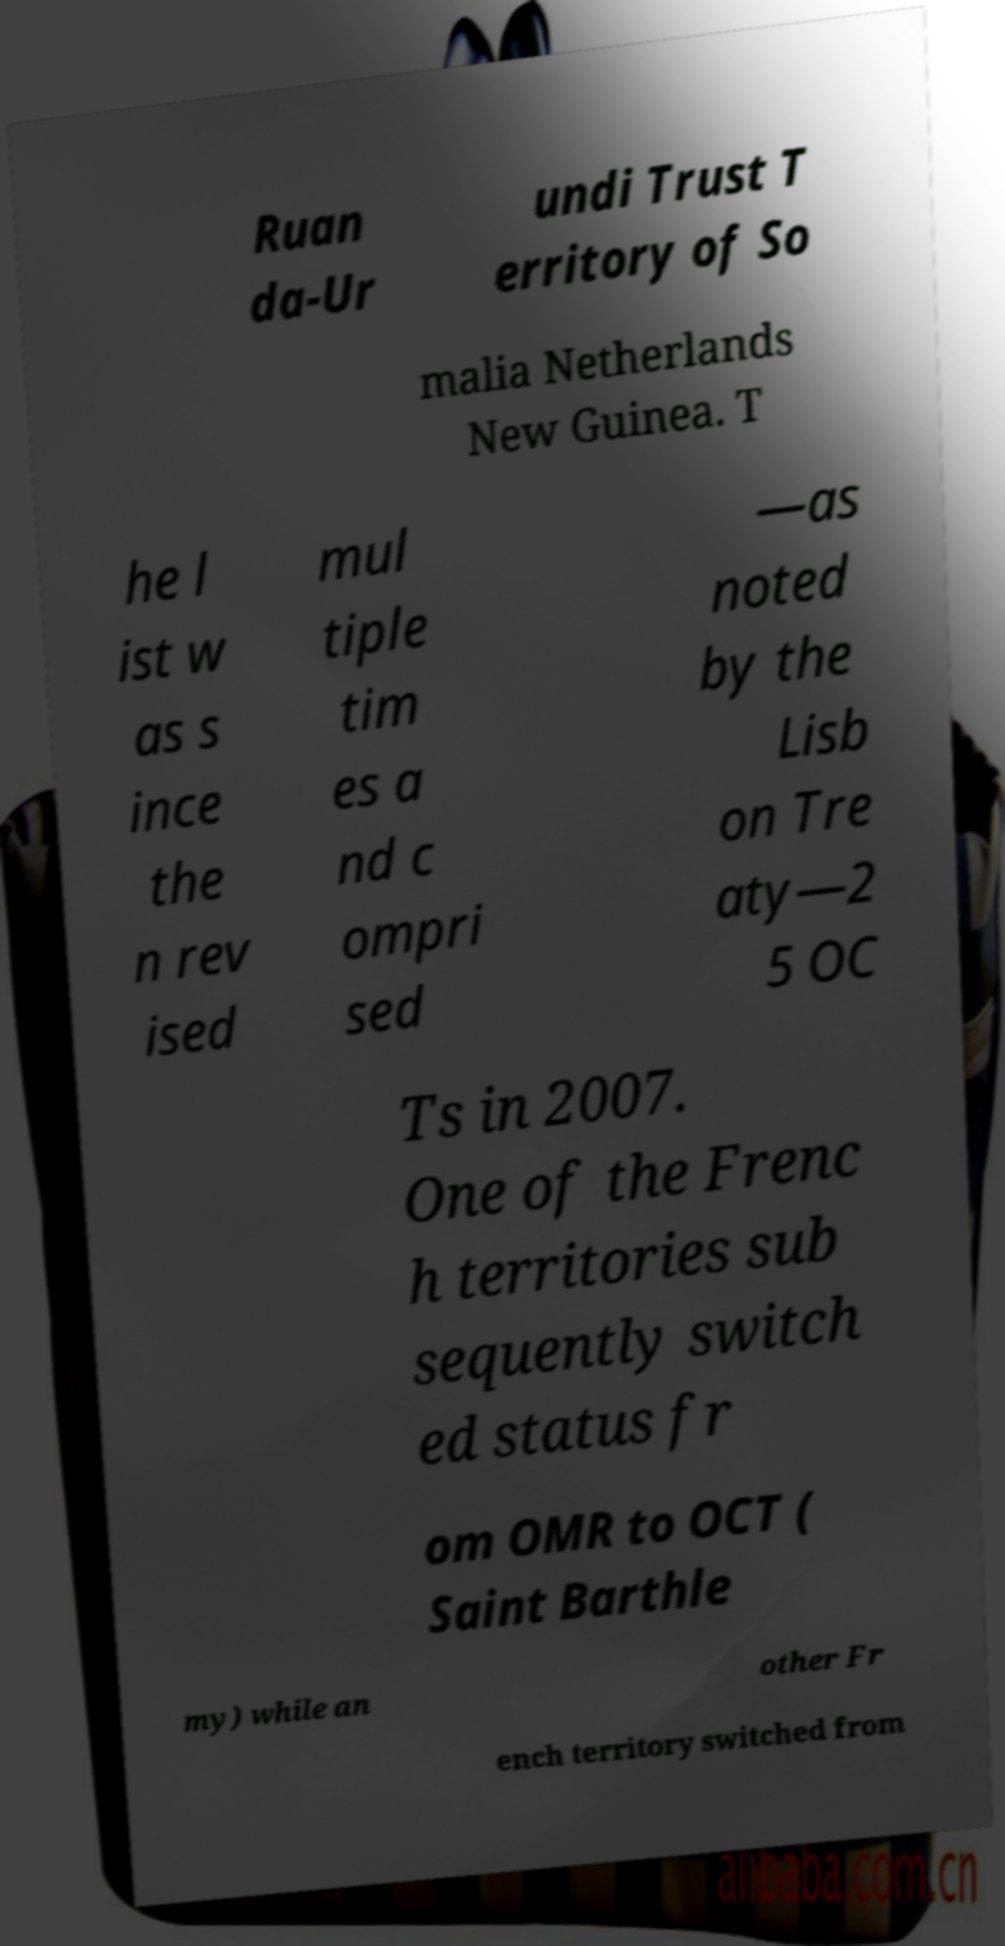I need the written content from this picture converted into text. Can you do that? Ruan da-Ur undi Trust T erritory of So malia Netherlands New Guinea. T he l ist w as s ince the n rev ised mul tiple tim es a nd c ompri sed —as noted by the Lisb on Tre aty—2 5 OC Ts in 2007. One of the Frenc h territories sub sequently switch ed status fr om OMR to OCT ( Saint Barthle my) while an other Fr ench territory switched from 